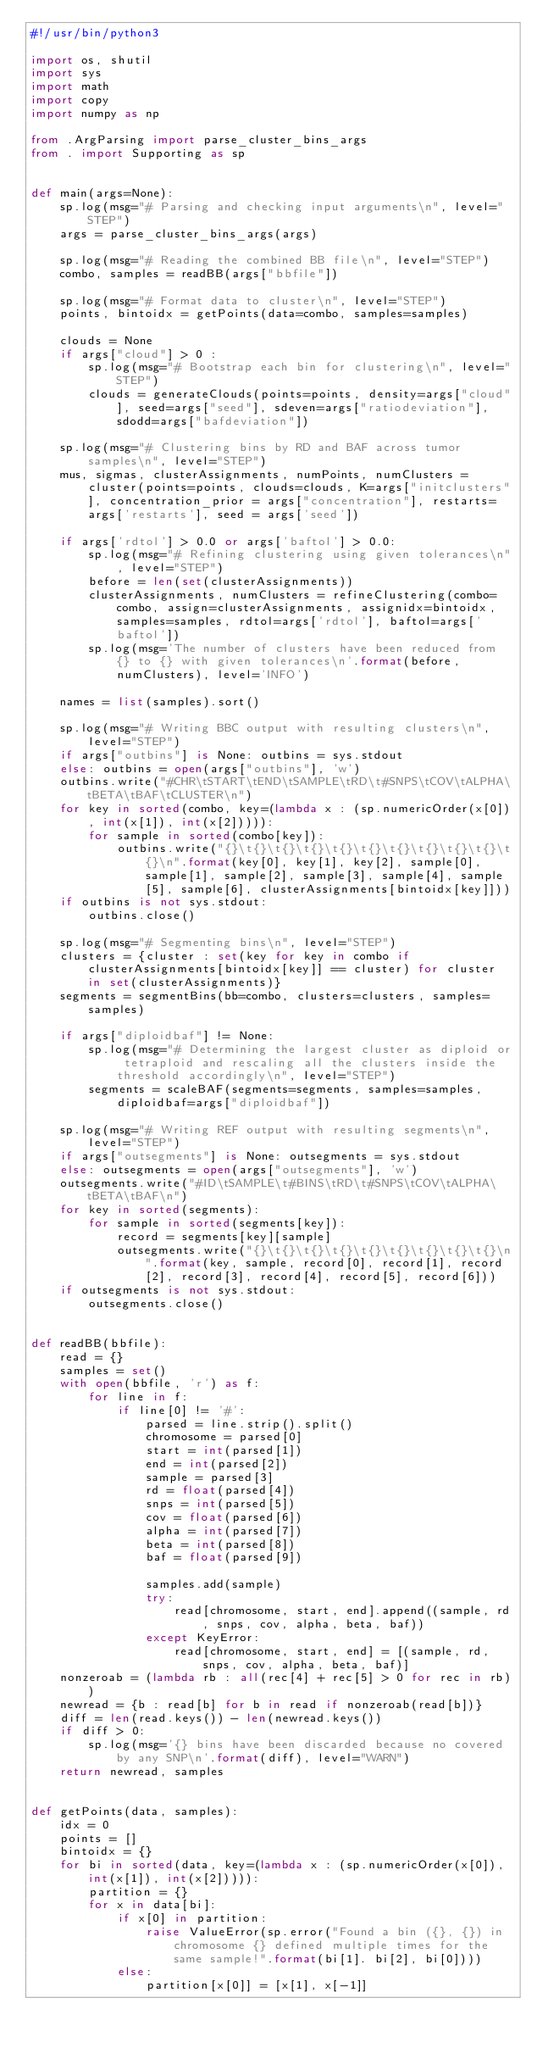<code> <loc_0><loc_0><loc_500><loc_500><_Python_>#!/usr/bin/python3

import os, shutil
import sys
import math
import copy
import numpy as np

from .ArgParsing import parse_cluster_bins_args
from . import Supporting as sp


def main(args=None):
    sp.log(msg="# Parsing and checking input arguments\n", level="STEP")
    args = parse_cluster_bins_args(args)

    sp.log(msg="# Reading the combined BB file\n", level="STEP")
    combo, samples = readBB(args["bbfile"])

    sp.log(msg="# Format data to cluster\n", level="STEP")
    points, bintoidx = getPoints(data=combo, samples=samples)

    clouds = None
    if args["cloud"] > 0 :
        sp.log(msg="# Bootstrap each bin for clustering\n", level="STEP")
        clouds = generateClouds(points=points, density=args["cloud"], seed=args["seed"], sdeven=args["ratiodeviation"], sdodd=args["bafdeviation"])

    sp.log(msg="# Clustering bins by RD and BAF across tumor samples\n", level="STEP")
    mus, sigmas, clusterAssignments, numPoints, numClusters = cluster(points=points, clouds=clouds, K=args["initclusters"], concentration_prior = args["concentration"], restarts=args['restarts'], seed = args['seed'])

    if args['rdtol'] > 0.0 or args['baftol'] > 0.0:
        sp.log(msg="# Refining clustering using given tolerances\n", level="STEP")
        before = len(set(clusterAssignments))
        clusterAssignments, numClusters = refineClustering(combo=combo, assign=clusterAssignments, assignidx=bintoidx, samples=samples, rdtol=args['rdtol'], baftol=args['baftol'])
        sp.log(msg='The number of clusters have been reduced from {} to {} with given tolerances\n'.format(before, numClusters), level='INFO')

    names = list(samples).sort()

    sp.log(msg="# Writing BBC output with resulting clusters\n", level="STEP")
    if args["outbins"] is None: outbins = sys.stdout
    else: outbins = open(args["outbins"], 'w')
    outbins.write("#CHR\tSTART\tEND\tSAMPLE\tRD\t#SNPS\tCOV\tALPHA\tBETA\tBAF\tCLUSTER\n")
    for key in sorted(combo, key=(lambda x : (sp.numericOrder(x[0]), int(x[1]), int(x[2])))):
        for sample in sorted(combo[key]):
            outbins.write("{}\t{}\t{}\t{}\t{}\t{}\t{}\t{}\t{}\t{}\t{}\n".format(key[0], key[1], key[2], sample[0], sample[1], sample[2], sample[3], sample[4], sample[5], sample[6], clusterAssignments[bintoidx[key]]))
    if outbins is not sys.stdout:
        outbins.close()

    sp.log(msg="# Segmenting bins\n", level="STEP")
    clusters = {cluster : set(key for key in combo if clusterAssignments[bintoidx[key]] == cluster) for cluster in set(clusterAssignments)}
    segments = segmentBins(bb=combo, clusters=clusters, samples=samples)

    if args["diploidbaf"] != None:
        sp.log(msg="# Determining the largest cluster as diploid or tetraploid and rescaling all the clusters inside the threshold accordingly\n", level="STEP")
        segments = scaleBAF(segments=segments, samples=samples, diploidbaf=args["diploidbaf"])

    sp.log(msg="# Writing REF output with resulting segments\n", level="STEP")
    if args["outsegments"] is None: outsegments = sys.stdout
    else: outsegments = open(args["outsegments"], 'w')
    outsegments.write("#ID\tSAMPLE\t#BINS\tRD\t#SNPS\tCOV\tALPHA\tBETA\tBAF\n")
    for key in sorted(segments):
        for sample in sorted(segments[key]):
            record = segments[key][sample]
            outsegments.write("{}\t{}\t{}\t{}\t{}\t{}\t{}\t{}\t{}\n".format(key, sample, record[0], record[1], record[2], record[3], record[4], record[5], record[6]))
    if outsegments is not sys.stdout:
        outsegments.close()


def readBB(bbfile):
    read = {}
    samples = set()
    with open(bbfile, 'r') as f:
        for line in f:
            if line[0] != '#':
                parsed = line.strip().split()
                chromosome = parsed[0]
                start = int(parsed[1])
                end = int(parsed[2])
                sample = parsed[3]
                rd = float(parsed[4])
                snps = int(parsed[5])
                cov = float(parsed[6])
                alpha = int(parsed[7])
                beta = int(parsed[8])
                baf = float(parsed[9])

                samples.add(sample)
                try:
                    read[chromosome, start, end].append((sample, rd, snps, cov, alpha, beta, baf))
                except KeyError:
                    read[chromosome, start, end] = [(sample, rd, snps, cov, alpha, beta, baf)]
    nonzeroab = (lambda rb : all(rec[4] + rec[5] > 0 for rec in rb))
    newread = {b : read[b] for b in read if nonzeroab(read[b])}
    diff = len(read.keys()) - len(newread.keys())
    if diff > 0:
        sp.log(msg='{} bins have been discarded because no covered by any SNP\n'.format(diff), level="WARN")
    return newread, samples


def getPoints(data, samples):
    idx = 0
    points = []
    bintoidx = {}
    for bi in sorted(data, key=(lambda x : (sp.numericOrder(x[0]), int(x[1]), int(x[2])))):
        partition = {}
        for x in data[bi]:
            if x[0] in partition:
                raise ValueError(sp.error("Found a bin ({}, {}) in chromosome {} defined multiple times for the same sample!".format(bi[1]. bi[2], bi[0])))
            else:
                partition[x[0]] = [x[1], x[-1]]</code> 